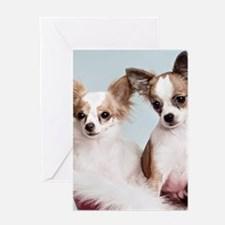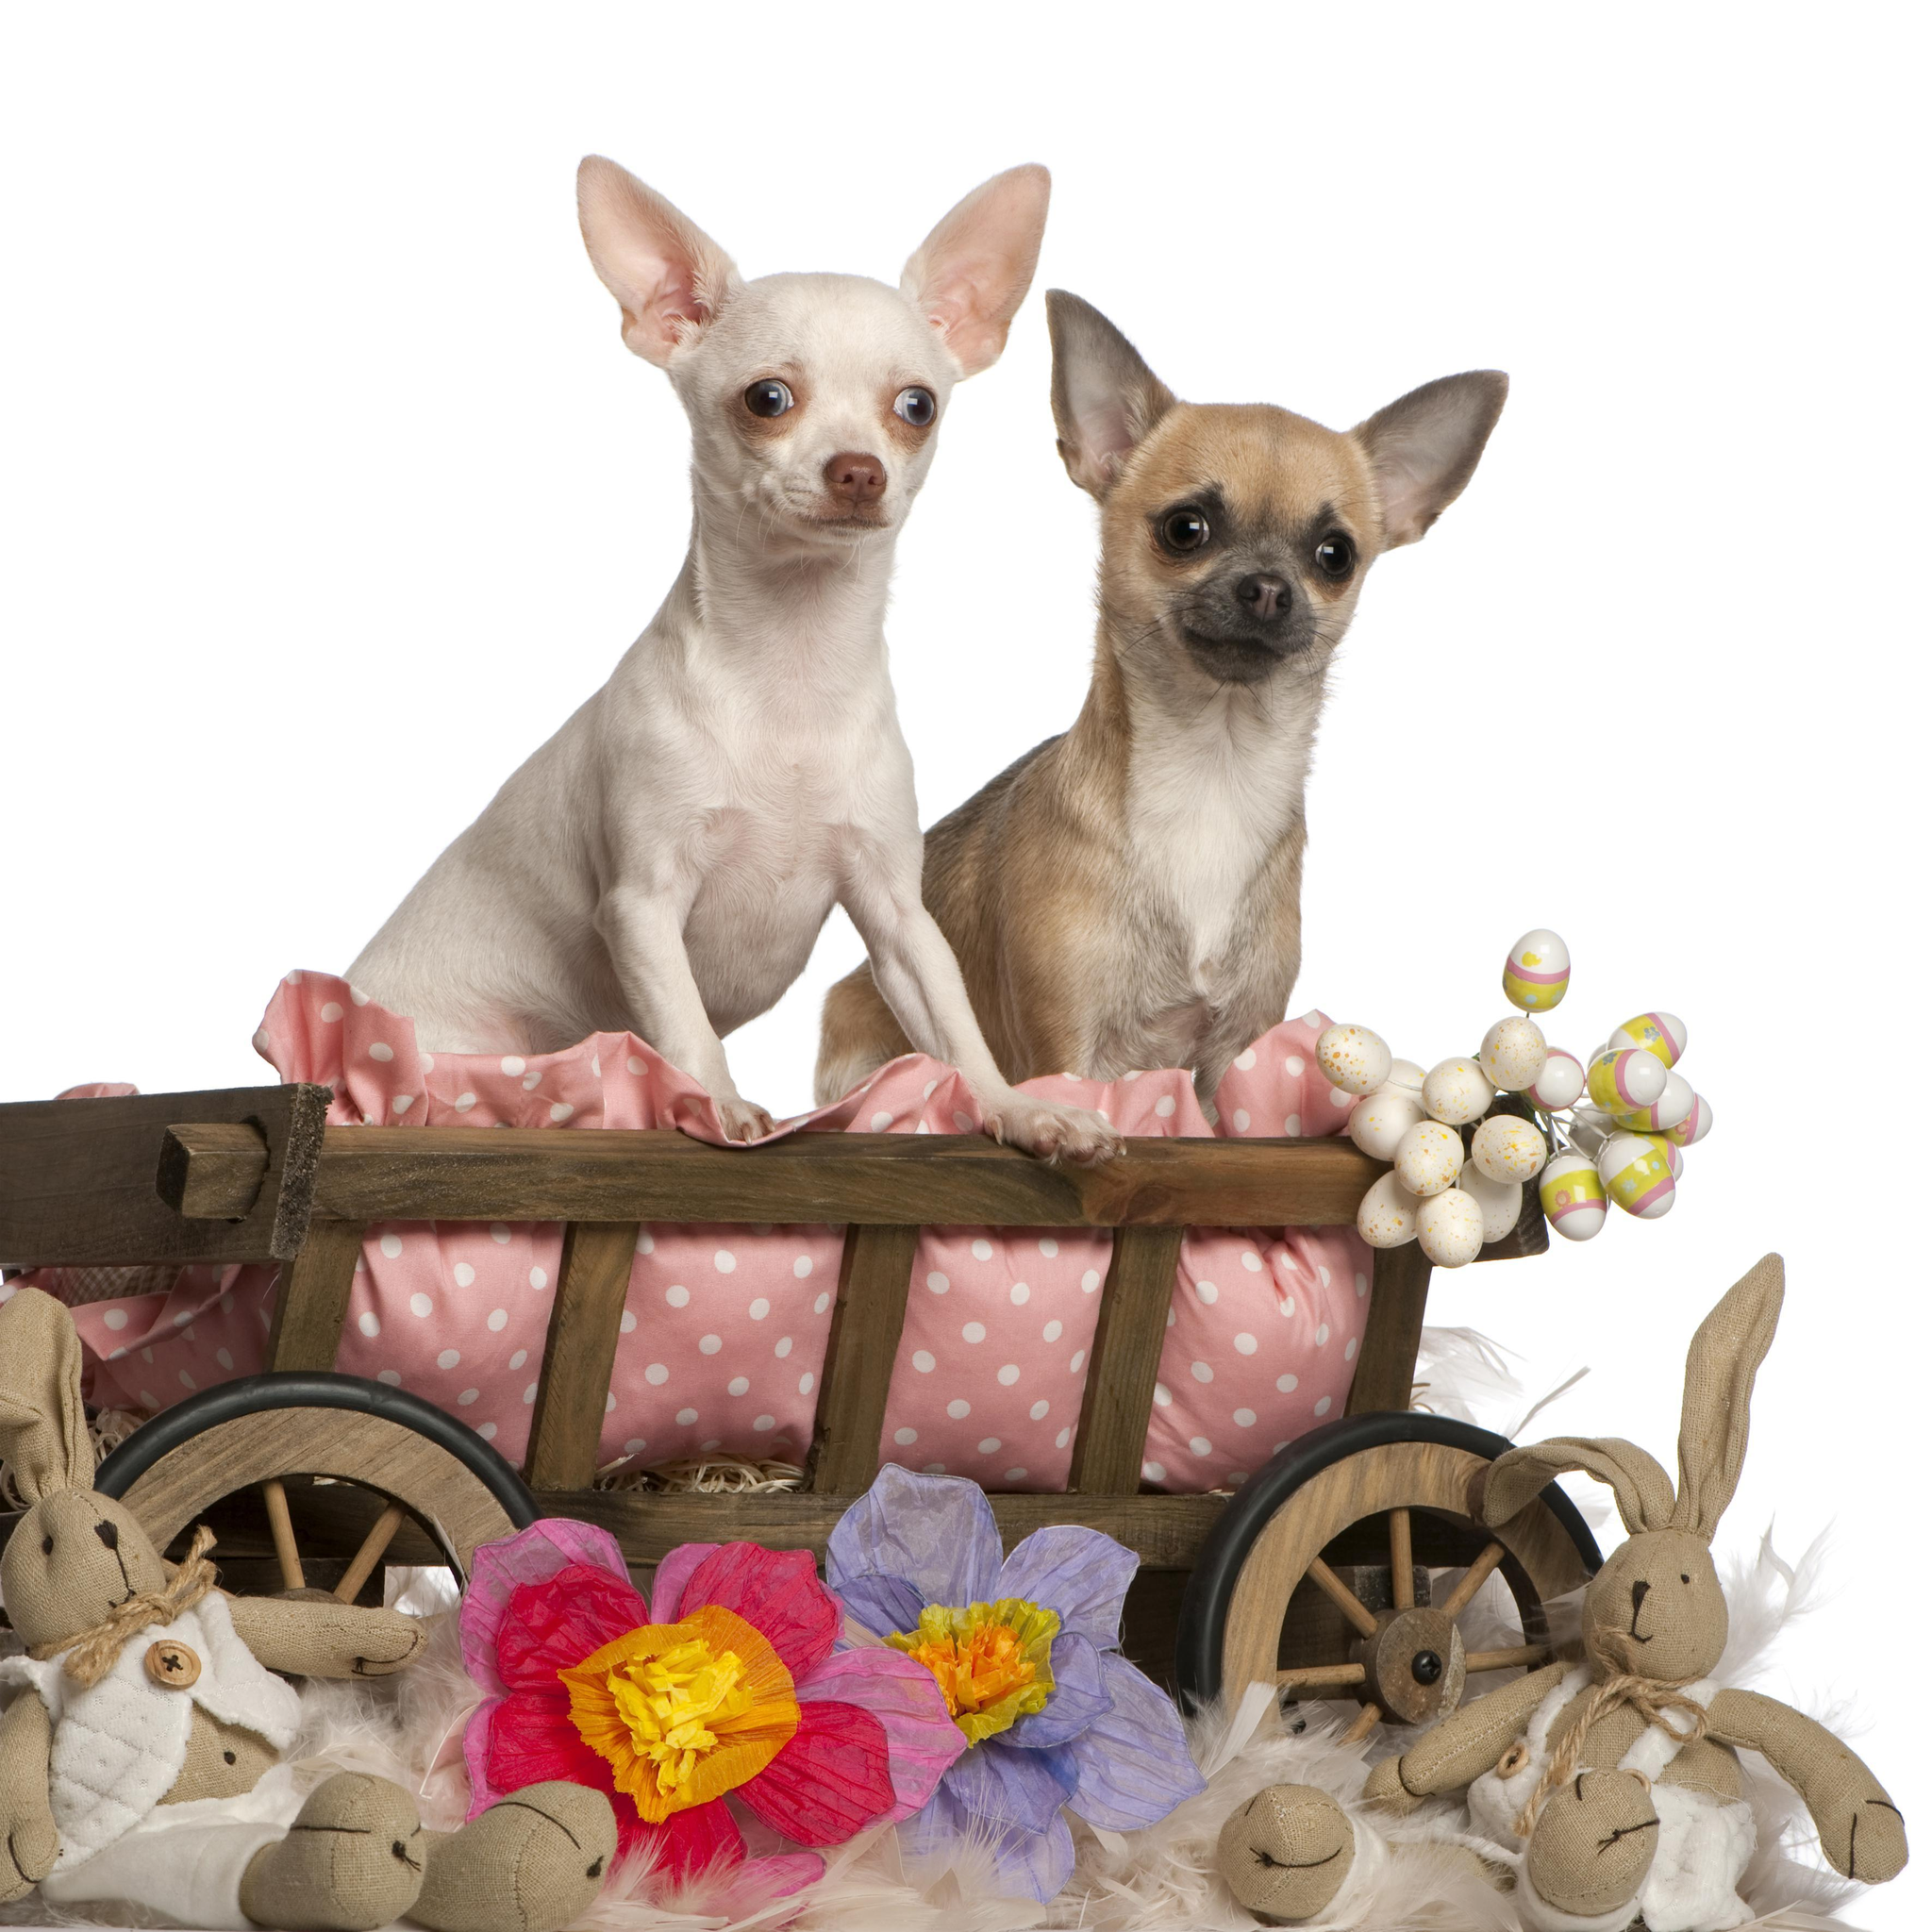The first image is the image on the left, the second image is the image on the right. Evaluate the accuracy of this statement regarding the images: "One image shows exactly two dogs with each dog in its own separate container or placemat; no two dogs share a spot.". Is it true? Answer yes or no. No. The first image is the image on the left, the second image is the image on the right. For the images shown, is this caption "An image includes two dogs, both in some type of container that features a polka-dotted pinkish element." true? Answer yes or no. Yes. 